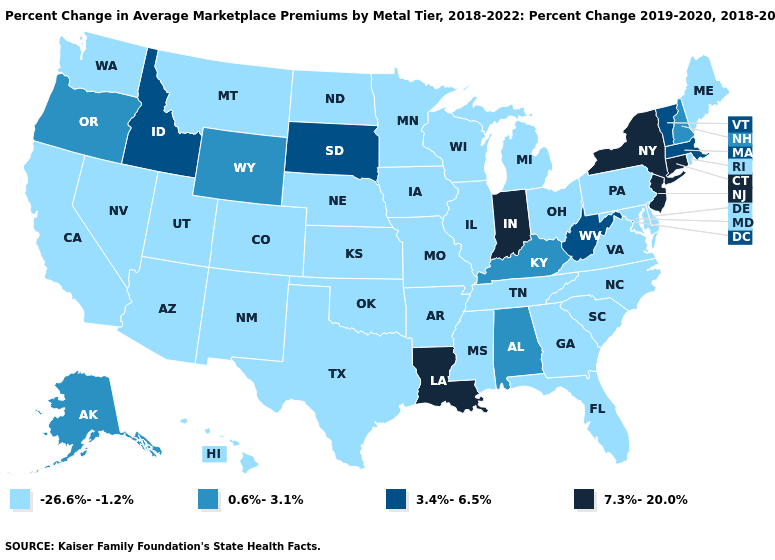Name the states that have a value in the range -26.6%--1.2%?
Write a very short answer. Arizona, Arkansas, California, Colorado, Delaware, Florida, Georgia, Hawaii, Illinois, Iowa, Kansas, Maine, Maryland, Michigan, Minnesota, Mississippi, Missouri, Montana, Nebraska, Nevada, New Mexico, North Carolina, North Dakota, Ohio, Oklahoma, Pennsylvania, Rhode Island, South Carolina, Tennessee, Texas, Utah, Virginia, Washington, Wisconsin. Among the states that border Maryland , does Virginia have the highest value?
Short answer required. No. What is the highest value in the MidWest ?
Short answer required. 7.3%-20.0%. Among the states that border Connecticut , which have the highest value?
Answer briefly. New York. What is the lowest value in states that border Wisconsin?
Answer briefly. -26.6%--1.2%. What is the highest value in states that border Idaho?
Give a very brief answer. 0.6%-3.1%. Does Idaho have the lowest value in the West?
Concise answer only. No. What is the value of West Virginia?
Be succinct. 3.4%-6.5%. Name the states that have a value in the range 7.3%-20.0%?
Give a very brief answer. Connecticut, Indiana, Louisiana, New Jersey, New York. Name the states that have a value in the range -26.6%--1.2%?
Be succinct. Arizona, Arkansas, California, Colorado, Delaware, Florida, Georgia, Hawaii, Illinois, Iowa, Kansas, Maine, Maryland, Michigan, Minnesota, Mississippi, Missouri, Montana, Nebraska, Nevada, New Mexico, North Carolina, North Dakota, Ohio, Oklahoma, Pennsylvania, Rhode Island, South Carolina, Tennessee, Texas, Utah, Virginia, Washington, Wisconsin. Name the states that have a value in the range 7.3%-20.0%?
Give a very brief answer. Connecticut, Indiana, Louisiana, New Jersey, New York. Name the states that have a value in the range -26.6%--1.2%?
Short answer required. Arizona, Arkansas, California, Colorado, Delaware, Florida, Georgia, Hawaii, Illinois, Iowa, Kansas, Maine, Maryland, Michigan, Minnesota, Mississippi, Missouri, Montana, Nebraska, Nevada, New Mexico, North Carolina, North Dakota, Ohio, Oklahoma, Pennsylvania, Rhode Island, South Carolina, Tennessee, Texas, Utah, Virginia, Washington, Wisconsin. Which states have the highest value in the USA?
Answer briefly. Connecticut, Indiana, Louisiana, New Jersey, New York. Name the states that have a value in the range 7.3%-20.0%?
Answer briefly. Connecticut, Indiana, Louisiana, New Jersey, New York. Name the states that have a value in the range 7.3%-20.0%?
Give a very brief answer. Connecticut, Indiana, Louisiana, New Jersey, New York. 